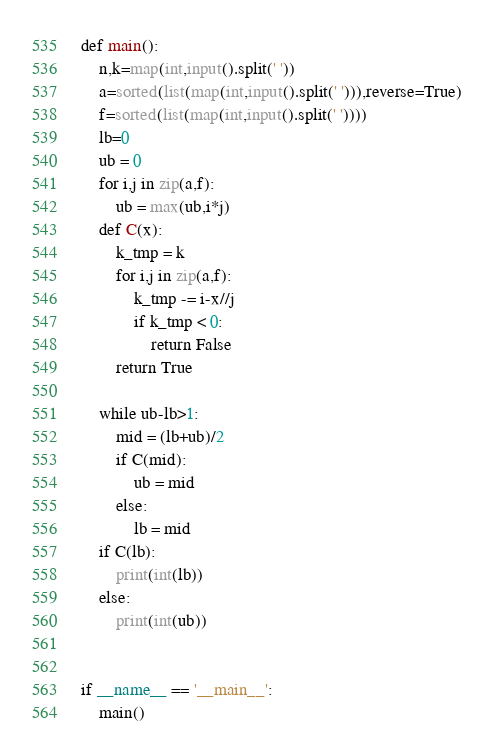Convert code to text. <code><loc_0><loc_0><loc_500><loc_500><_Python_>
def main():
    n,k=map(int,input().split(' '))
    a=sorted(list(map(int,input().split(' '))),reverse=True)
    f=sorted(list(map(int,input().split(' '))))
    lb=0
    ub = 0
    for i,j in zip(a,f):
        ub = max(ub,i*j)
    def C(x):
        k_tmp = k
        for i,j in zip(a,f):
            k_tmp -= i-x//j
            if k_tmp < 0:
                return False
        return True

    while ub-lb>1:
        mid = (lb+ub)/2
        if C(mid):
            ub = mid
        else:
            lb = mid
    if C(lb):
        print(int(lb))
    else:
        print(int(ub))


if __name__ == '__main__':
    main()
</code> 